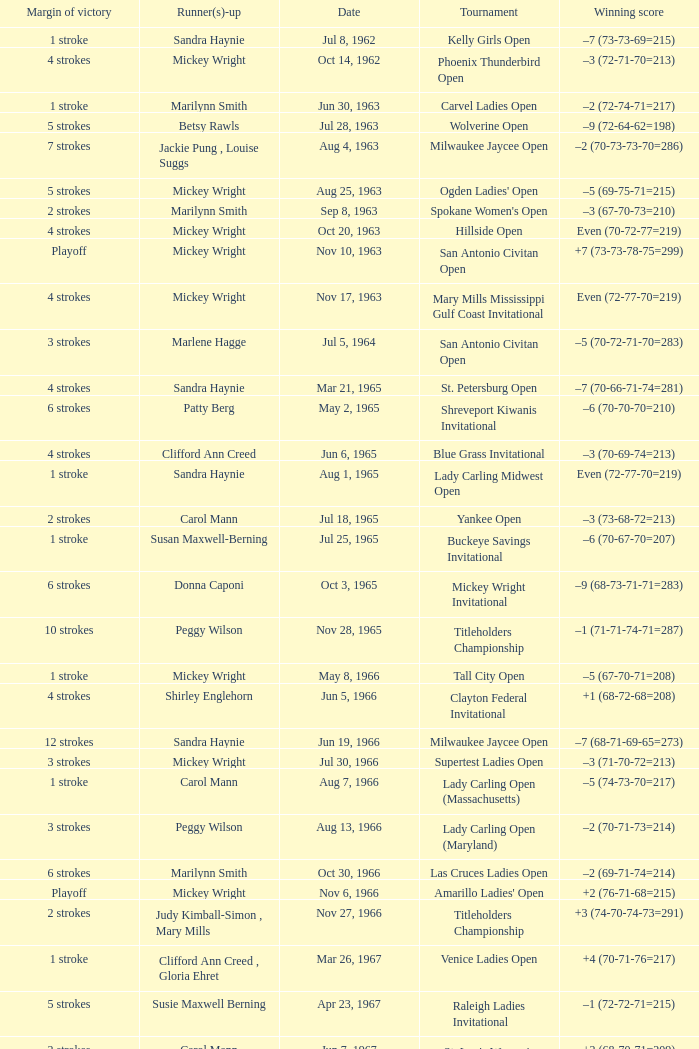What was the margin of victory on Apr 23, 1967? 5 strokes. 